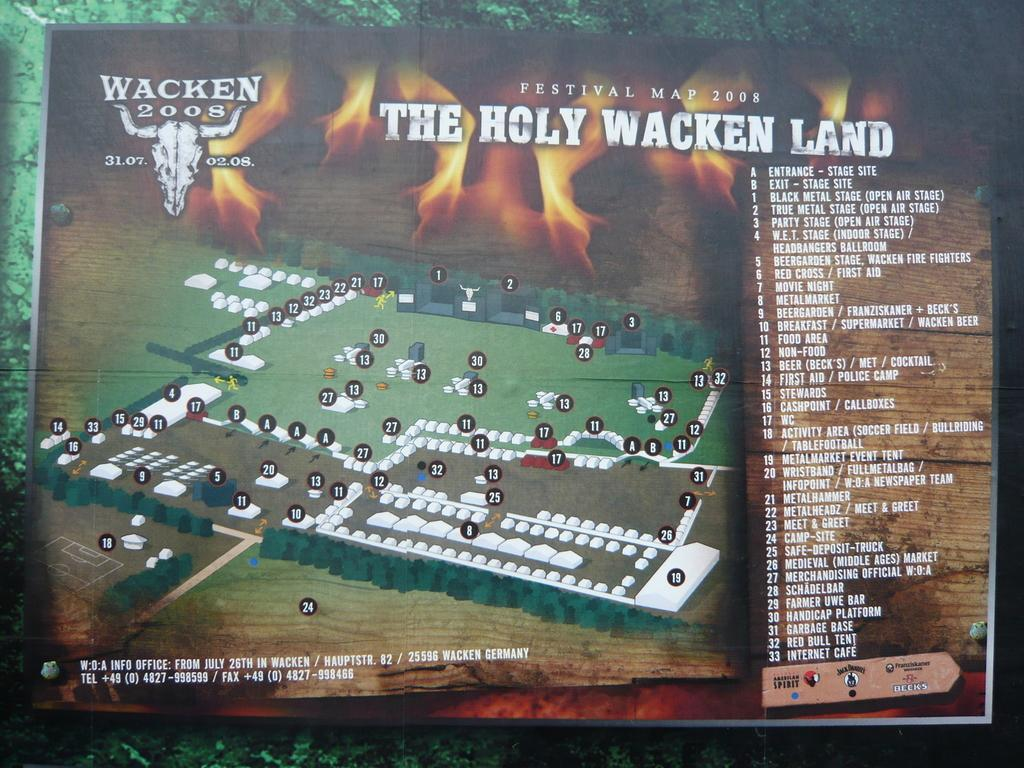What is the main object in the image? There is a board in the image. What is depicted on the left side of the board? There is a map on the left side of the board. What can be found on the other sides of the board? There is writing on the other sides of the board. How many lines are visible on the board in the image? There is no mention of lines in the provided facts, so it is impossible to determine the number of lines on the board. 